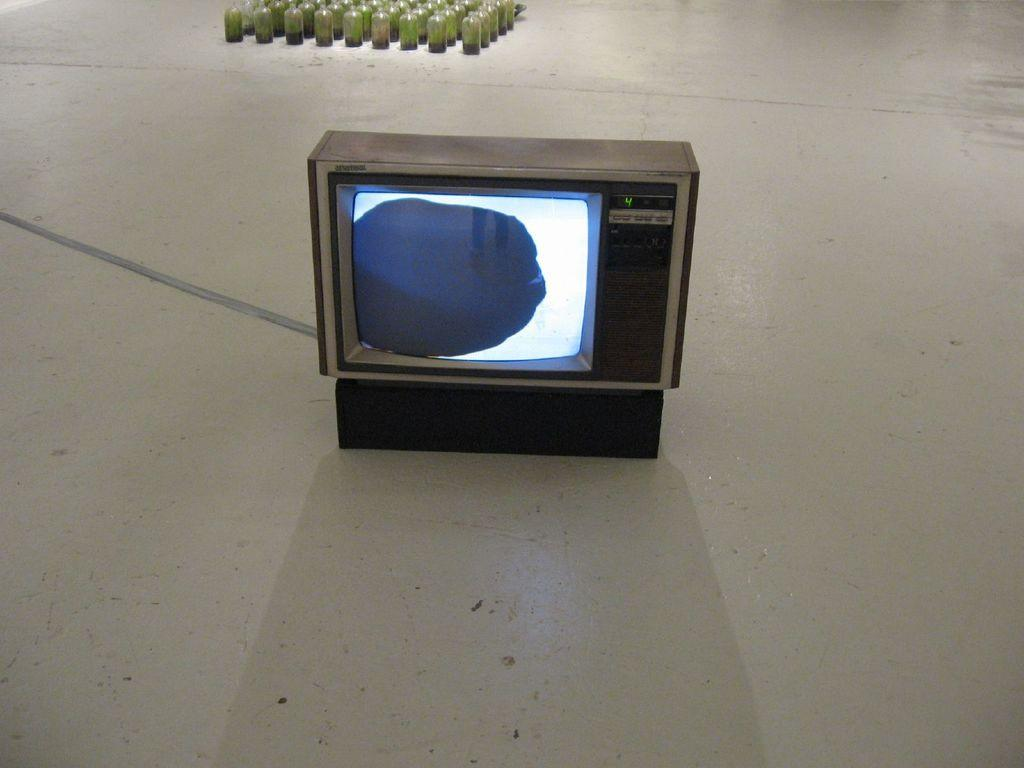What electronic device can be seen on the ground in the image? There is a television on the ground in the image. What object appears to be partially visible or cut off towards the left side of the image? There is an object truncated towards the left of the image. What type of objects are partially visible or cut off towards the top of the image? There are bottles truncated towards the top of the image. What type of bridge can be seen in the image? There is no bridge present in the image. Can you provide a list of all the items observed in the image? Based on the provided facts, we can only confirm the presence of a television, an object truncated towards the left, and bottles truncated towards the top. 